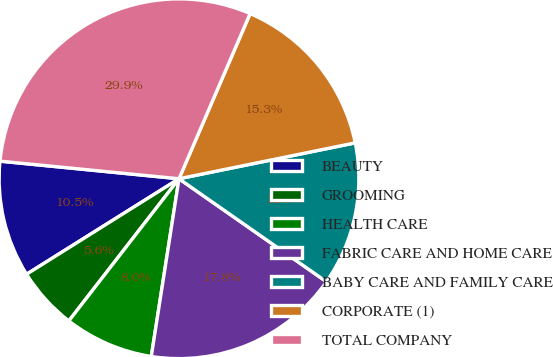Convert chart to OTSL. <chart><loc_0><loc_0><loc_500><loc_500><pie_chart><fcel>BEAUTY<fcel>GROOMING<fcel>HEALTH CARE<fcel>FABRIC CARE AND HOME CARE<fcel>BABY CARE AND FAMILY CARE<fcel>CORPORATE (1)<fcel>TOTAL COMPANY<nl><fcel>10.47%<fcel>5.6%<fcel>8.03%<fcel>17.76%<fcel>12.9%<fcel>15.33%<fcel>29.91%<nl></chart> 